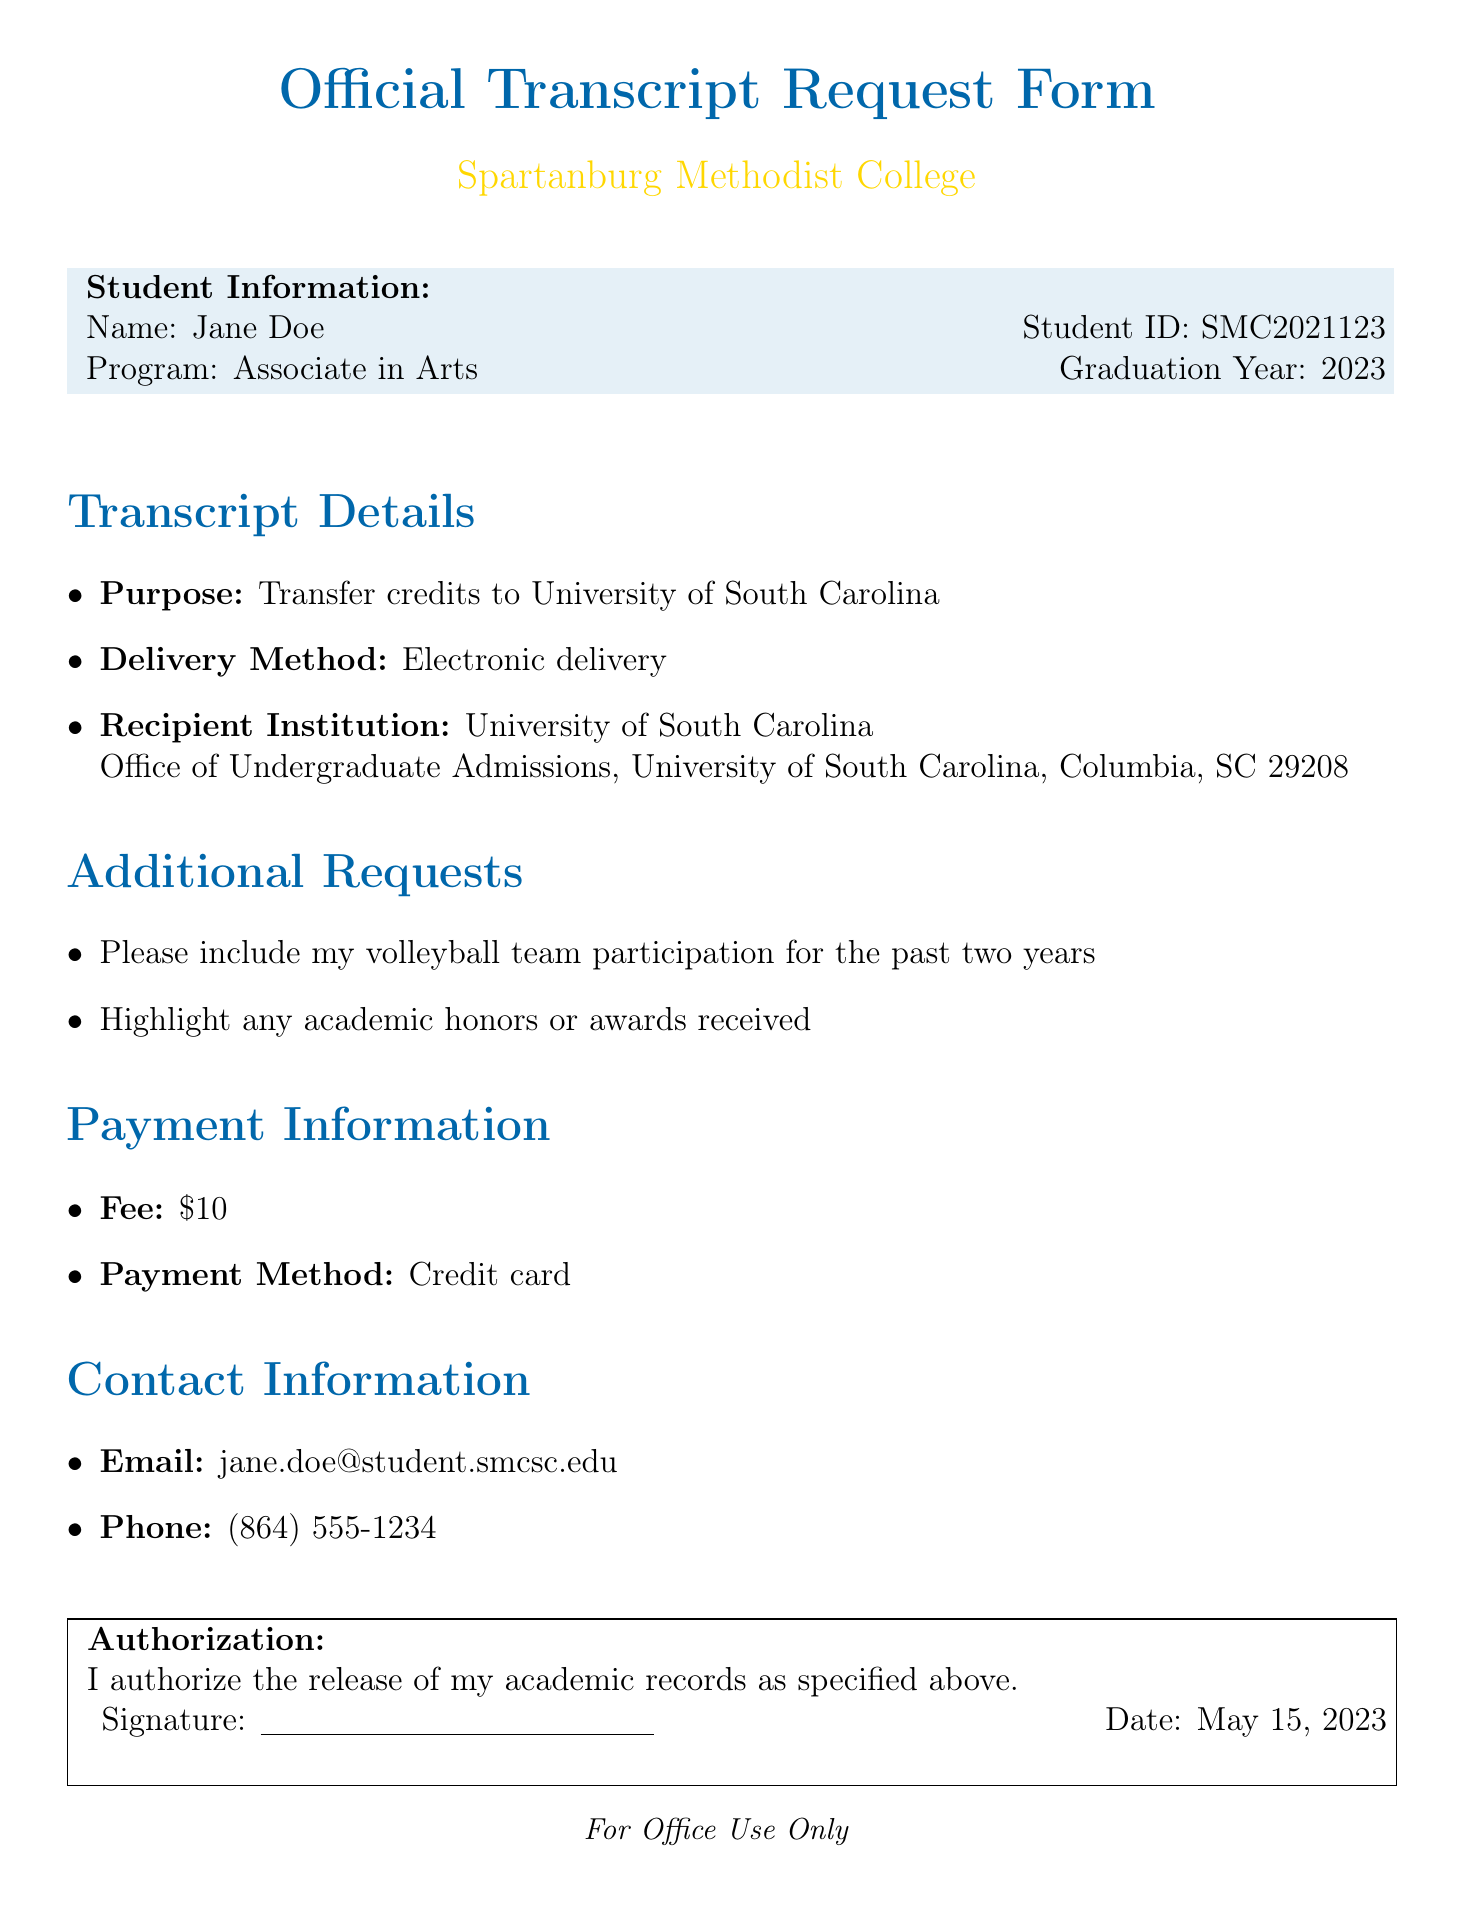What is the subject of the document? The subject is explicitly stated at the top of the document, indicating the main focus of the email.
Answer: Request for Official Transcript for Credit Transfer Who is the recipient of the request? The document specifies the department to which the request is being sent.
Answer: Registrar's Office, Spartanburg Methodist College What is the purpose of the transcript request? The purpose is clearly mentioned in the document, specifying the intended use of the transcript.
Answer: Transfer credits to University of South Carolina What method of delivery is requested for the transcript? The delivery method is clearly stated in the document.
Answer: Electronic delivery What fee must be paid for the transcript? The document lists the fee required for processing the transcript request.
Answer: $10 What information is requested to be included in the transcript? The additional requests section outlines specific information the student wants highlighted.
Answer: volleyball team participation What is the student's email address? The student's contact information is provided in the document.
Answer: jane.doe@student.smcsc.edu What is the date of the authorization statement? The date is specified in the signature section of the document.
Answer: May 15, 2023 Which institution is receiving the transcript? The document states the name and address of the recipient institution for the transcript.
Answer: University of South Carolina, Office of Undergraduate Admissions, University of South Carolina, Columbia, SC 29208 